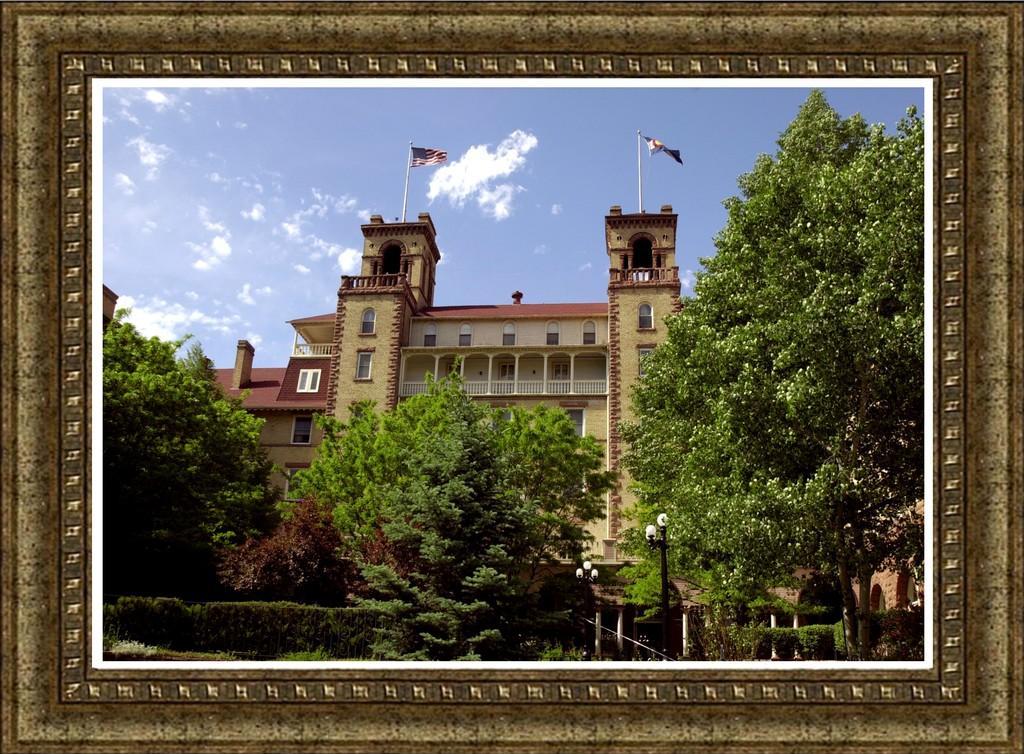How would you summarize this image in a sentence or two? In this image there is a photo frame, there is the sky, there are clouds in the sky, there is a building, there are poles, there are flags, there are windows, there are lights, there are trees, there are plants. 